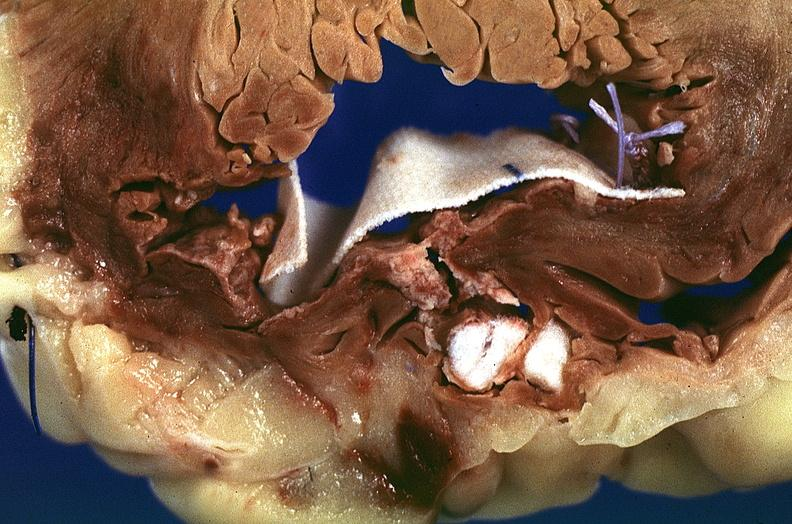what does this image show?
Answer the question using a single word or phrase. Heart 